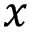<formula> <loc_0><loc_0><loc_500><loc_500>x</formula> 